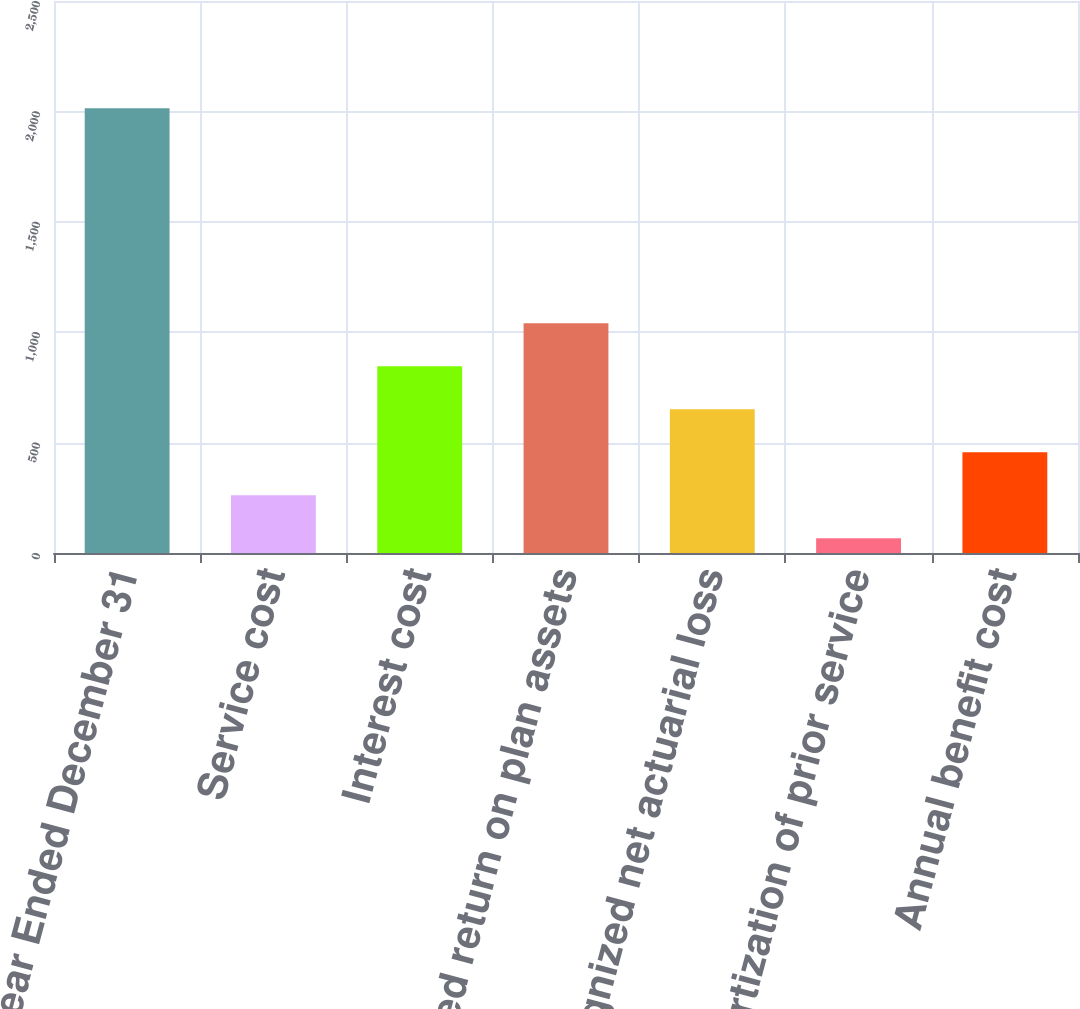Convert chart to OTSL. <chart><loc_0><loc_0><loc_500><loc_500><bar_chart><fcel>Year Ended December 31<fcel>Service cost<fcel>Interest cost<fcel>Expected return on plan assets<fcel>Recognized net actuarial loss<fcel>Amortization of prior service<fcel>Annual benefit cost<nl><fcel>2014<fcel>261.7<fcel>845.8<fcel>1040.5<fcel>651.1<fcel>67<fcel>456.4<nl></chart> 